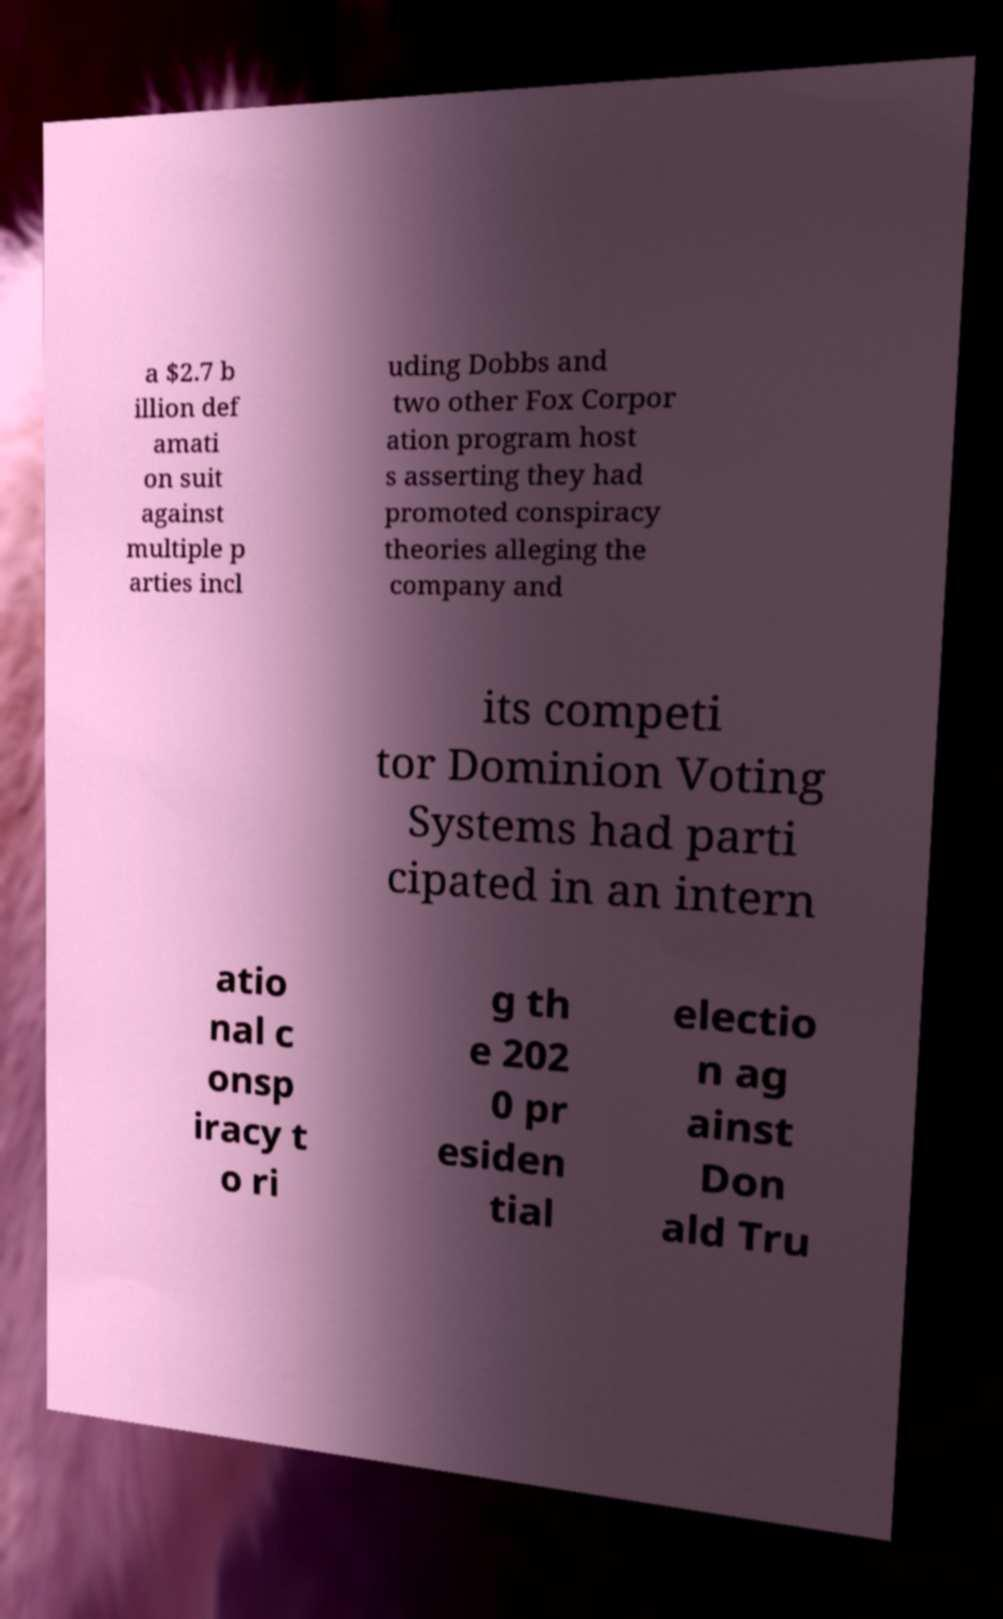Can you read and provide the text displayed in the image?This photo seems to have some interesting text. Can you extract and type it out for me? a $2.7 b illion def amati on suit against multiple p arties incl uding Dobbs and two other Fox Corpor ation program host s asserting they had promoted conspiracy theories alleging the company and its competi tor Dominion Voting Systems had parti cipated in an intern atio nal c onsp iracy t o ri g th e 202 0 pr esiden tial electio n ag ainst Don ald Tru 